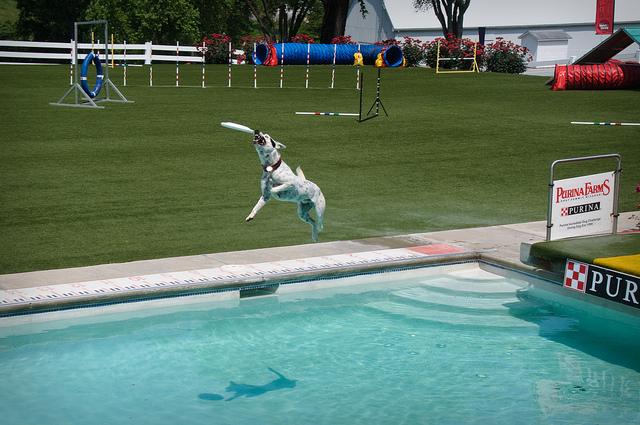Is the dog catching a frisbee?
Answer briefly. Yes. Is there water in the pool?
Concise answer only. Yes. Is the dog swimming?
Be succinct. No. 